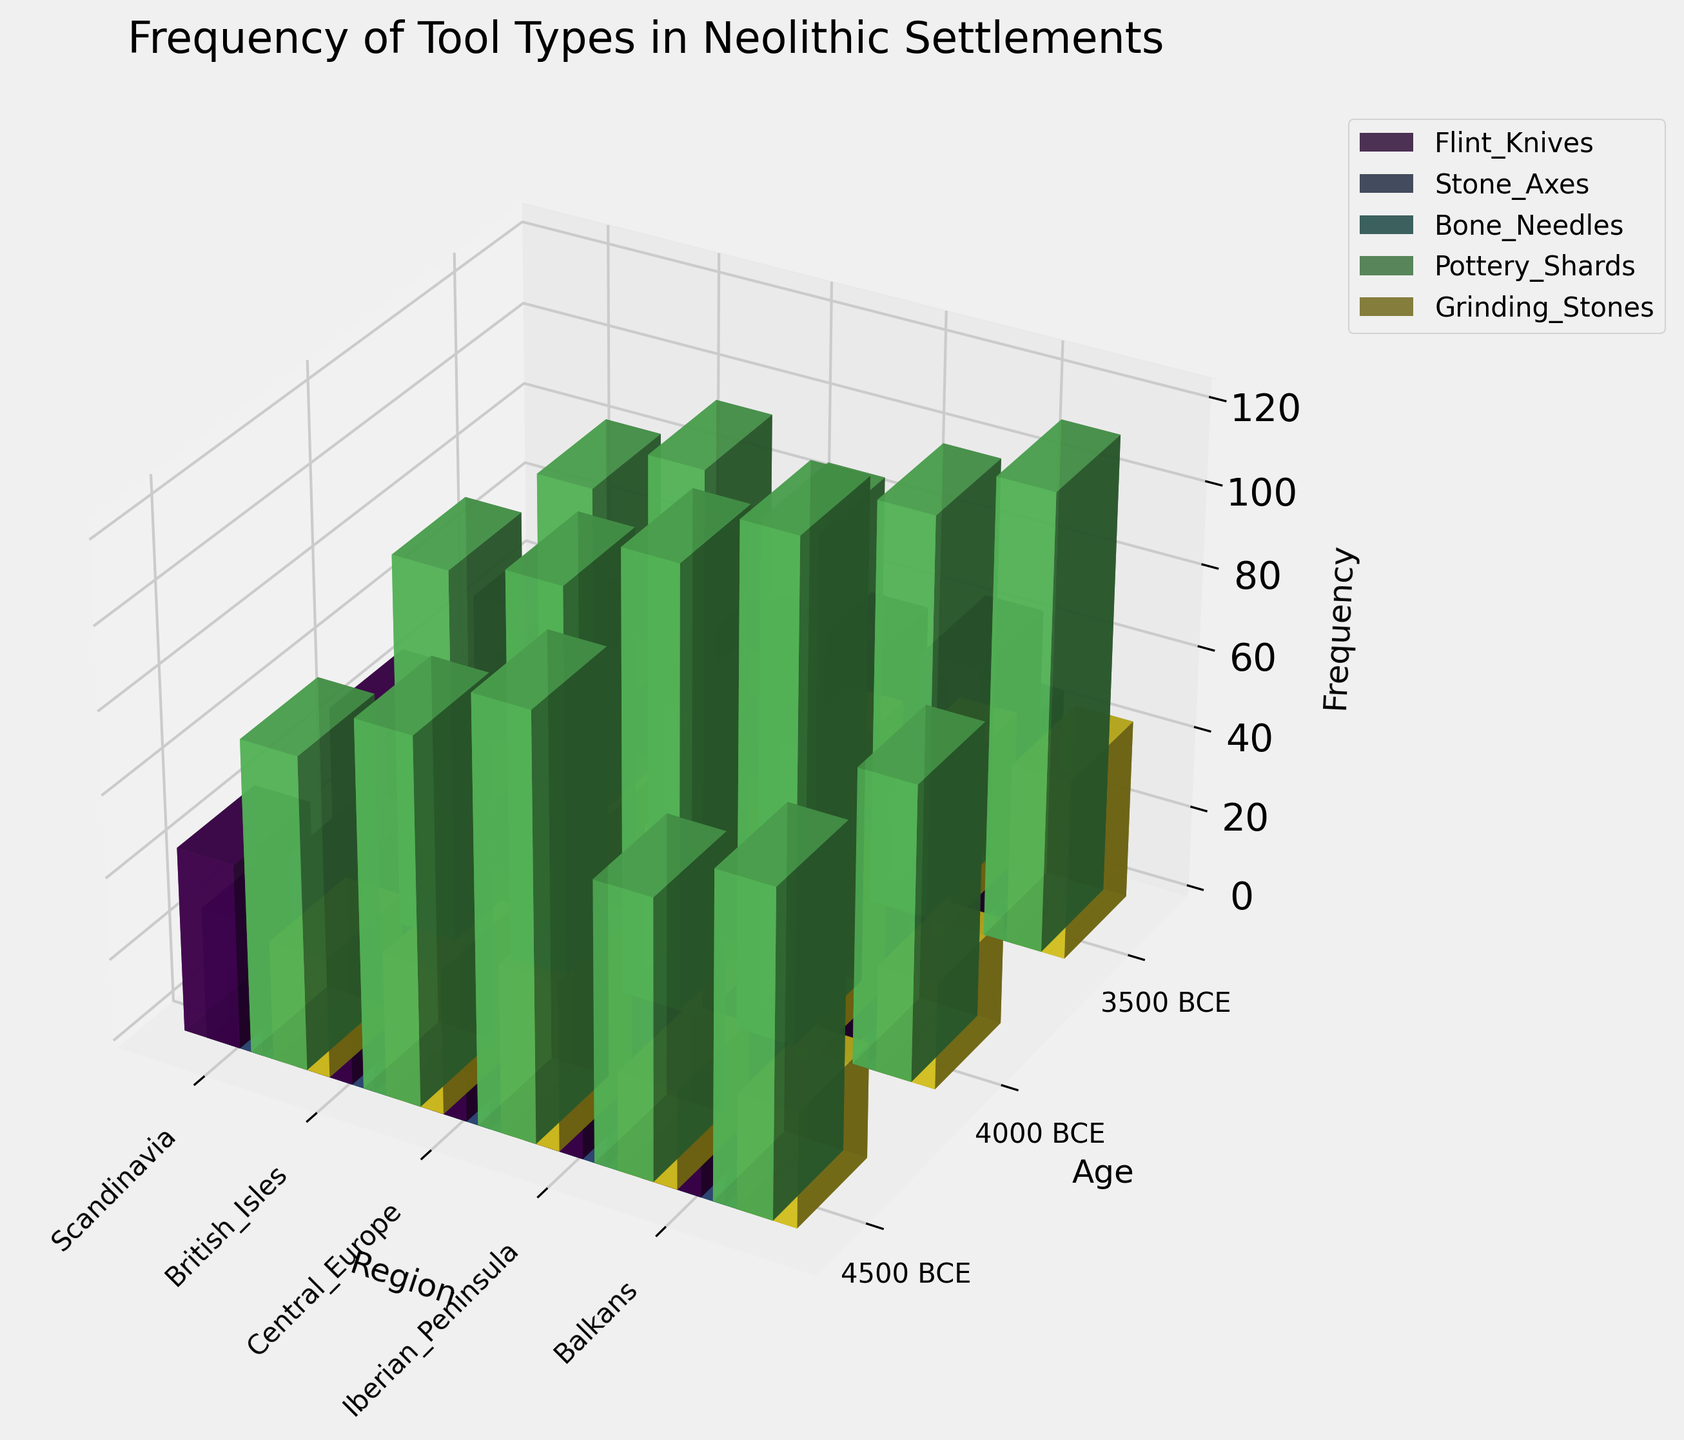What is the title of the figure? The title is located at the top of the figure.
Answer: Frequency of Tool Types in Neolithic Settlements Which region shows the highest frequency of Pottery Shards in 3500 BCE? Identify the bar for Pottery Shards at 3500 BCE for each region and compare their heights.
Answer: Central Europe How much greater is the frequency of Flint Knives in British Isles from 4500 BCE to 4000 BCE? Subtract the frequency of Flint Knives in 4500 BCE from that in 4000 BCE for the British Isles.
Answer: 5 What is the average frequency of Stone Axes in Scandinavia for all the given ages? Add the values of Stone Axes in Scandinavia across the ages and divide by the number of age points (which is 3).
Answer: (32 + 38 + 43) / 3 = 37.67 Which tool type has the lowest overall frequency in the Iberian Peninsula at any given time point? Examine the height of each bar representing different tool types in the Iberian Peninsula across all ages, noting the minimum.
Answer: Bone Needles Are there any tool types that show a consistently increasing frequency over time in Central Europe? Analyze the trend across the given ages for each tool type in Central Europe, looking for consistently rising bars.
Answer: Yes, Pottery Shards and Grinding Stones How does the frequency of Stone Axes in the Balkans around 4500 BCE compare to that in Central Europe around the same period? Compare the heights of the bars representing Stone Axes in the Balkans and Central Europe around 4500 BCE.
Answer: It is lower in the Balkans Which tool type has the most significant difference in frequency between the British Isles and the Iberian Peninsula in 3500 BCE? Calculate the difference in frequencies for each tool type between the two regions in 3500 BCE and identify the greatest difference.
Answer: Pottery Shards What is the total frequency of Bone Needles in all regions at 4000 BCE? Add the frequencies of Bone Needles across all regions at 4000 BCE.
Answer: 22 + 19 + 27 + 20 + 24 = 112 In which region and age is the frequency of Grinding Stones the highest? Locate the bar representing Grinding Stones with the maximum height.
Answer: Central Europe, 3500 BCE 